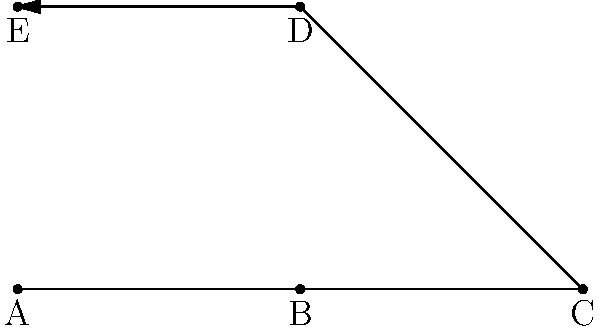In a traditional Japanese kata for sword techniques, the practitioner moves through a series of positions. Given the diagram showing the sequence of movements, which of the following represents the correct order of positions? To determine the correct sequence of movements in this kata, we need to follow the arrow path in the diagram:

1. The sequence starts at point A, which is the initial stance.
2. The arrow leads from A to B, indicating the first movement.
3. From B, the arrow continues to C, showing the second movement.
4. The third movement is represented by the arrow moving from C to D.
5. Finally, the arrow completes the sequence by moving from D to E.

Therefore, the correct sequence of positions in this kata is A → B → C → D → E.
Answer: ABCDE 